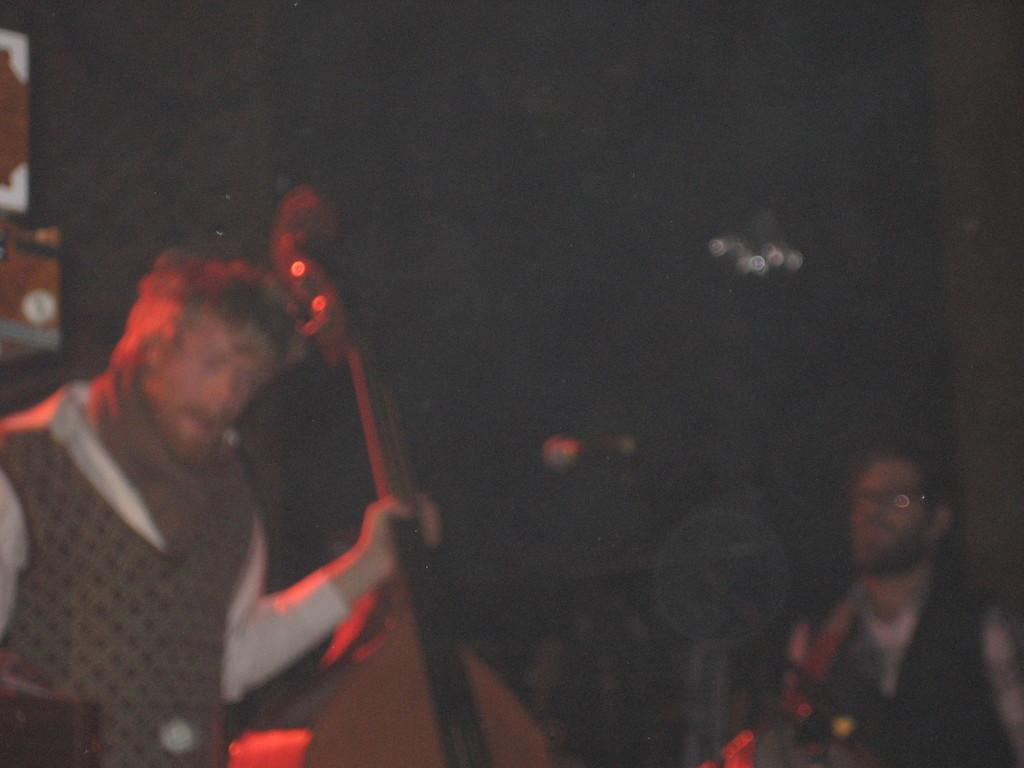How many people are in the image? There are two persons in the image. What are the persons doing in the image? The persons are holding musical instruments. Can you describe the lighting in the image? The setting is dark. What type of cork can be seen in the image? There is no cork present in the image. How do the persons react to the sound of their musical instruments in the image? The image does not show any reaction from the persons, so it cannot be determined from the image. 